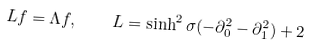Convert formula to latex. <formula><loc_0><loc_0><loc_500><loc_500>L f = \Lambda f , \quad L = \sinh ^ { 2 } \sigma ( - \partial _ { 0 } ^ { 2 } - \partial _ { 1 } ^ { 2 } ) + 2</formula> 